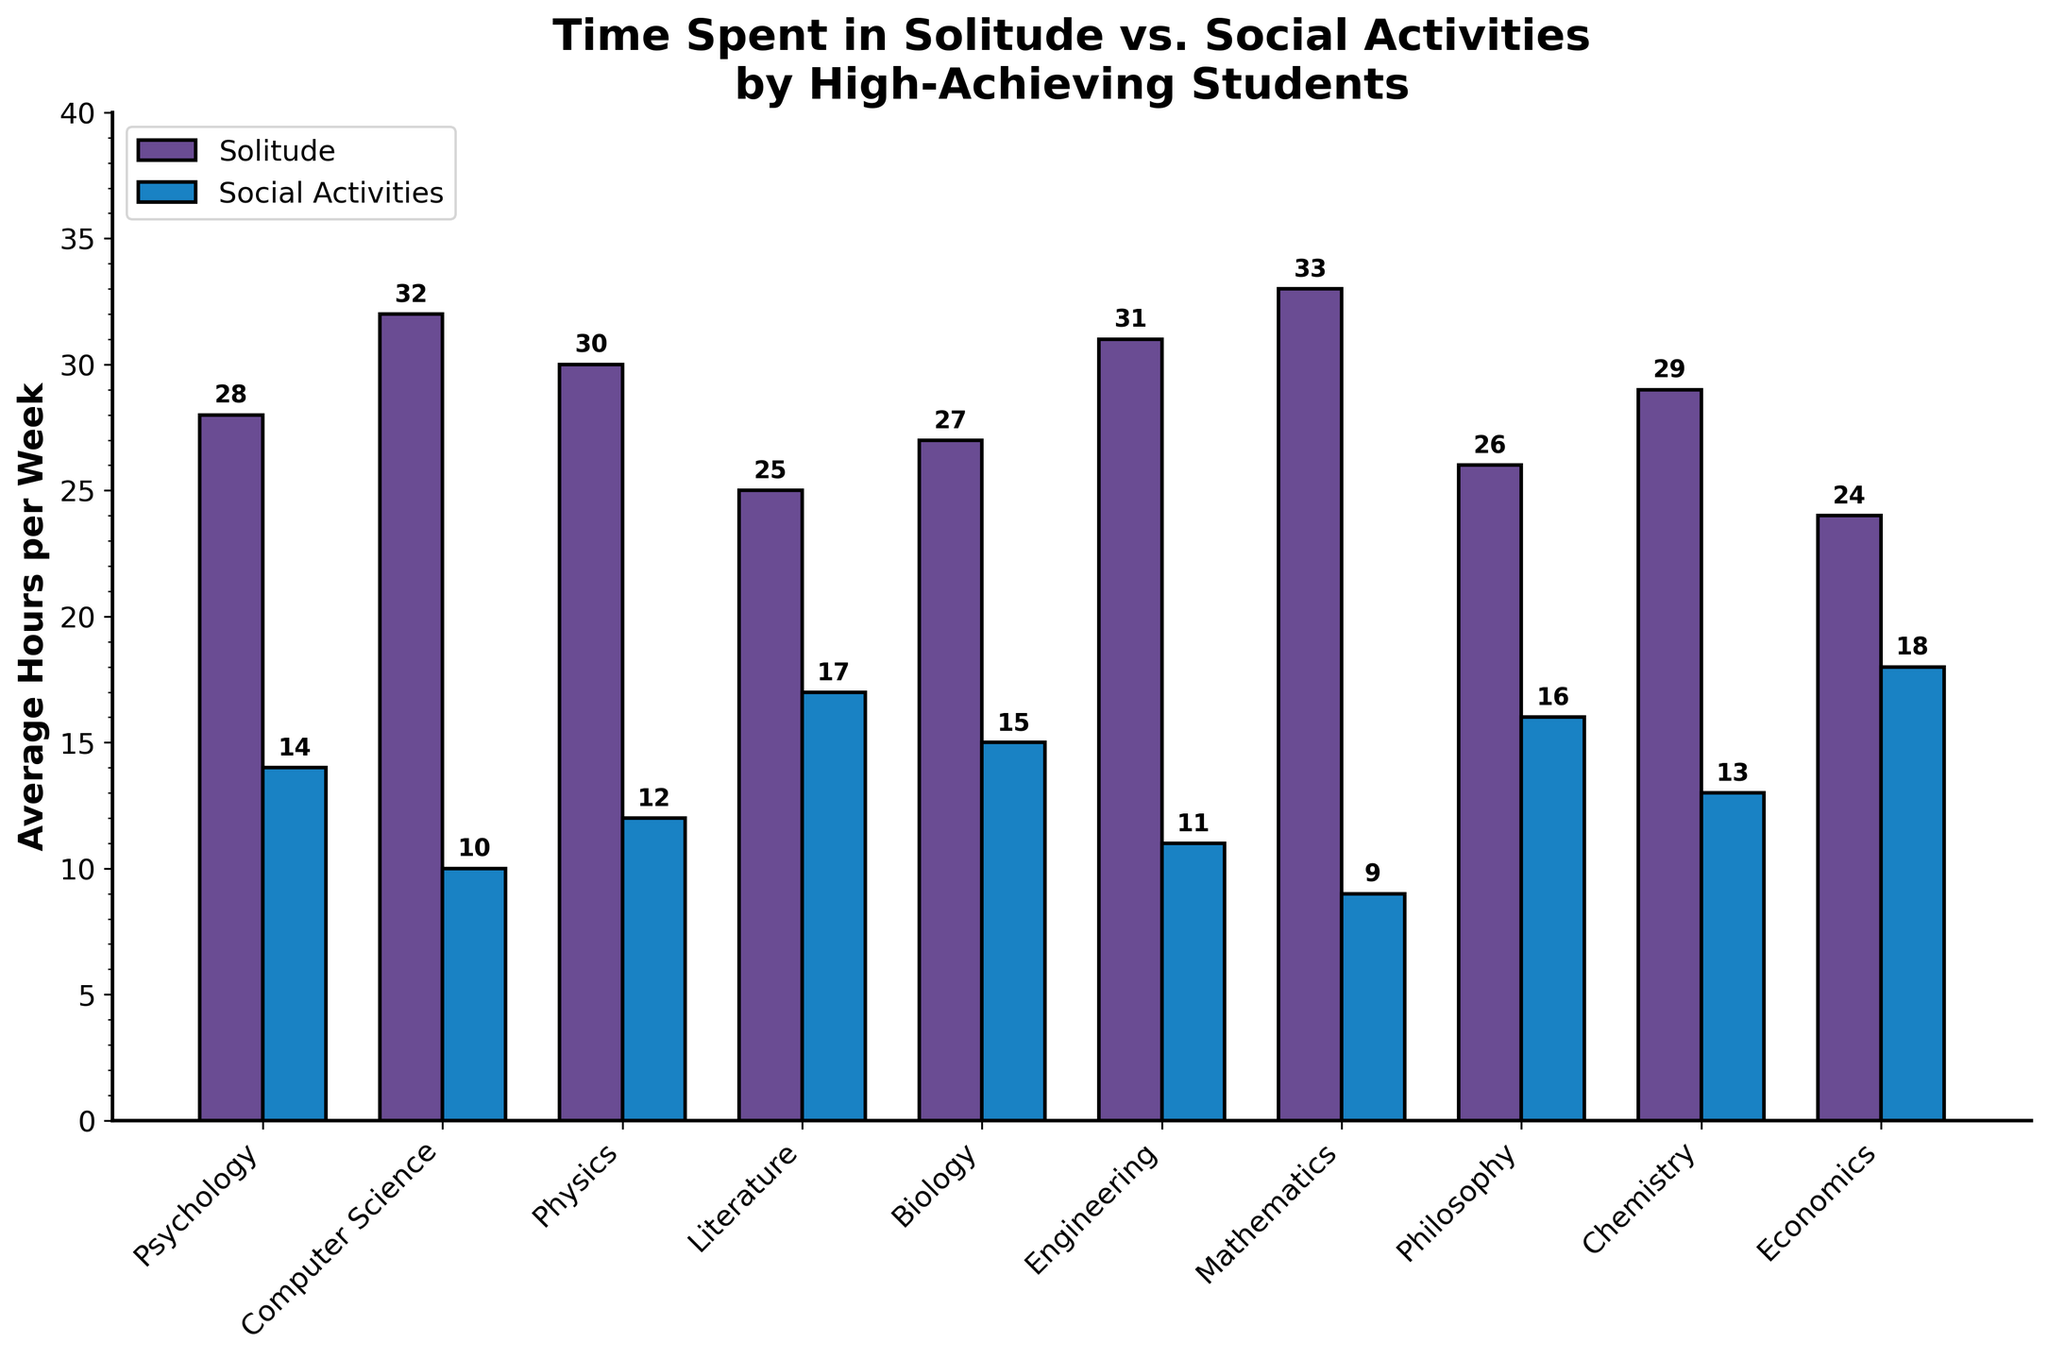What field of study has the highest average hours in solitude per week? By examining the height of the bars for solitude across all the fields, Mathematics has the tallest bar, representing the highest average hours in solitude.
Answer: Mathematics Which field spends more time in social activities: Psychology or Philosophy? We compare the height of the social activities bars for Psychology and Philosophy. The bar for Philosophy is taller than the one for Psychology.
Answer: Philosophy What is the total amount of hours spent in solitude and social activities by Computer Science students per week? To find the total, we sum the average hours in solitude (32) and the average hours in social activities (10) for Computer Science students. The calculation is 32 + 10 = 42.
Answer: 42 How do the average hours in solitude compare between Biology and Chemistry students? We look at the bars representing solitude hours for Biology and Chemistry. The bar for Chemistry is slightly taller than the bar for Biology, indicating Chemistry students spend more time in solitude.
Answer: Chemistry students spend more time in solitude Which field has the smallest difference between hours spent in solitude and social activities? To find the field with the smallest difference, we calculate the difference for each field and compare. Economics has a difference of 6 hours (24 hours in solitude - 18 hours in social activities), which is the smallest.
Answer: Economics For Literature students, what is the ratio of time spent in solitude to time spent in social activities? To find the ratio, we divide the average hours in solitude (25) by the average hours in social activities (17). The calculation is 25 / 17 ≈ 1.47.
Answer: 1.47 Among all fields, which one has the highest combined average for solitude and social activities? We sum the average hours in solitude and social activities for each field, then compare these sums. Computer Science has a combined sum of 42 hours (32 + 10), which is the highest among all fields.
Answer: Computer Science What is the difference in solitude hours between the field with the highest solitude average and the field with the lowest solitude average? The field with the highest solitude average is Mathematics (33 hours), and the field with the lowest is Economics (24 hours). The difference is calculated as 33 - 24 = 9.
Answer: 9 Do any fields spend more time on social activities than solitude? If so, which ones? To determine this, we compare the heights of solitude and social activities bars within each field. Economics is the only field where the social activities bar is taller than the solitude bar.
Answer: Economics 